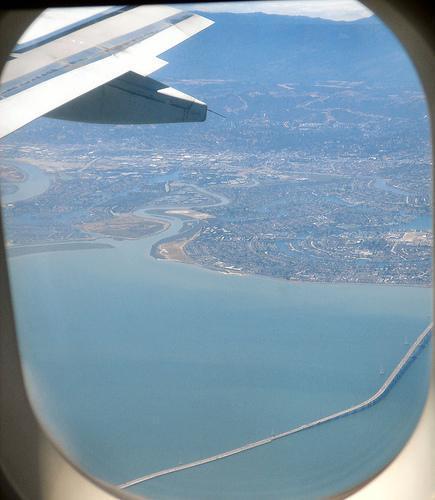How many windows are in the photo?
Give a very brief answer. 1. How many airplanes are in the scene?
Give a very brief answer. 1. How many lakes are to the right of the inlet?
Give a very brief answer. 5. 